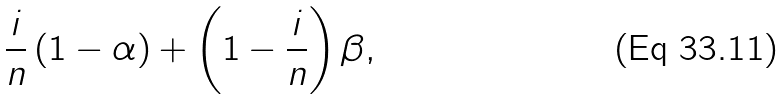<formula> <loc_0><loc_0><loc_500><loc_500>\frac { i } { n } \left ( 1 - \alpha \right ) + \left ( 1 - \frac { i } { n } \right ) \beta ,</formula> 